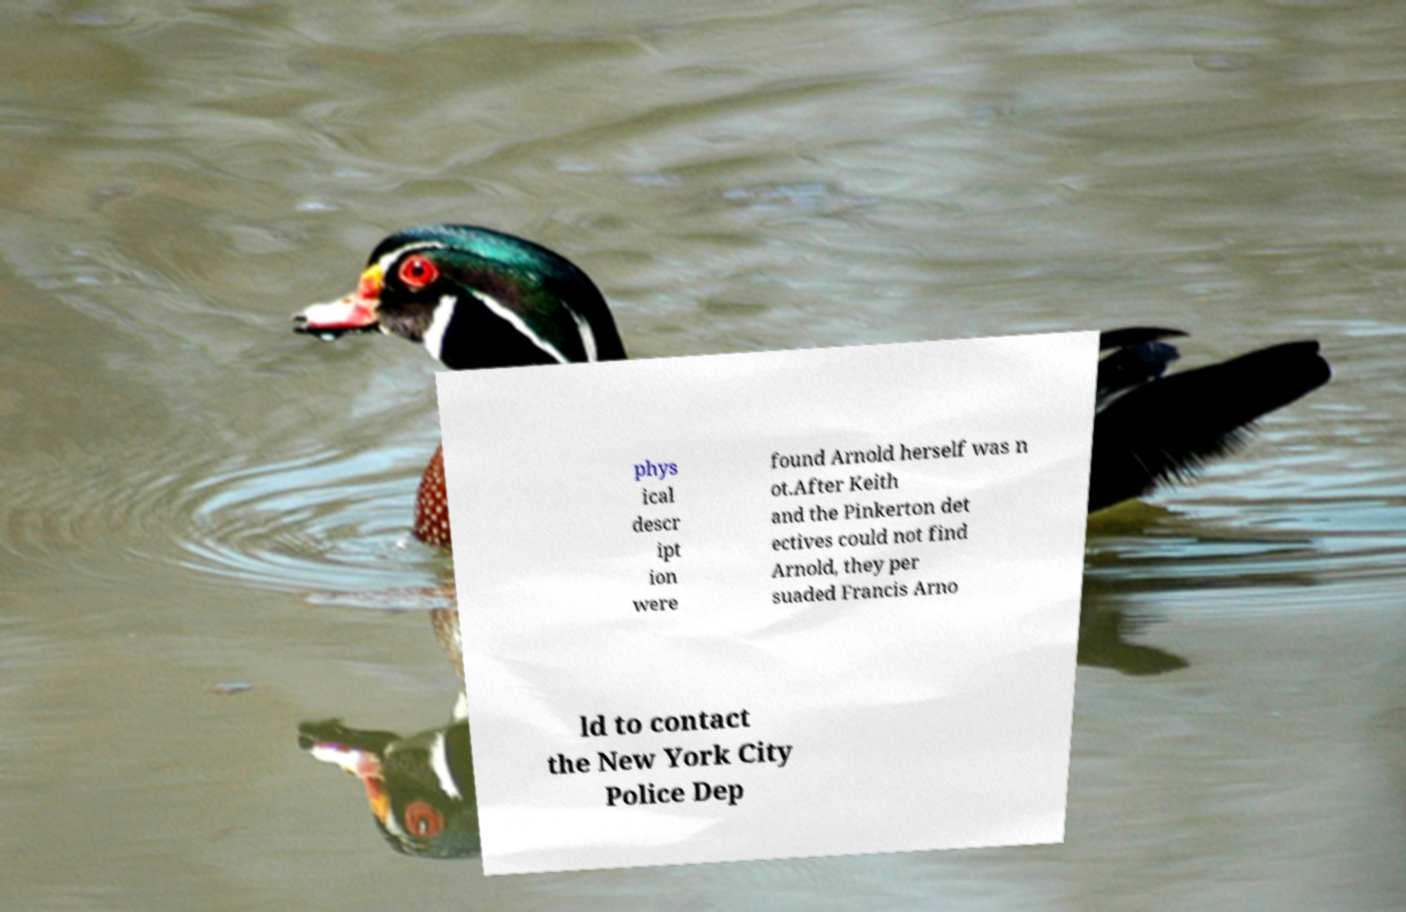There's text embedded in this image that I need extracted. Can you transcribe it verbatim? phys ical descr ipt ion were found Arnold herself was n ot.After Keith and the Pinkerton det ectives could not find Arnold, they per suaded Francis Arno ld to contact the New York City Police Dep 